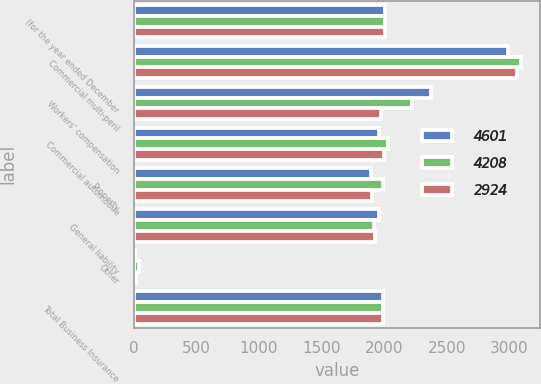<chart> <loc_0><loc_0><loc_500><loc_500><stacked_bar_chart><ecel><fcel>(for the year ended December<fcel>Commercial multi-peril<fcel>Workers' compensation<fcel>Commercial automobile<fcel>Property<fcel>General liability<fcel>Other<fcel>Total Business Insurance<nl><fcel>4601<fcel>2008<fcel>2988<fcel>2373<fcel>1957<fcel>1895<fcel>1959<fcel>8<fcel>1989<nl><fcel>4208<fcel>2007<fcel>3087<fcel>2221<fcel>2026<fcel>1989<fcel>1917<fcel>43<fcel>1989<nl><fcel>2924<fcel>2006<fcel>3056<fcel>1970<fcel>1999<fcel>1901<fcel>1929<fcel>21<fcel>1989<nl></chart> 